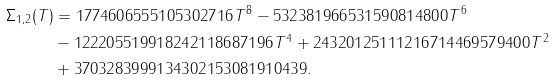<formula> <loc_0><loc_0><loc_500><loc_500>\Sigma _ { 1 , 2 } ( T ) & = 1 7 7 4 6 0 6 5 5 5 1 0 5 3 0 2 7 1 6 T ^ { 8 } - 5 3 2 3 8 1 9 6 6 5 3 1 5 9 0 8 1 4 8 0 0 T ^ { 6 } \\ & - 1 2 2 2 0 5 5 1 9 9 1 8 2 4 2 1 1 8 6 8 7 1 9 6 T ^ { 4 } + 2 4 3 2 0 1 2 5 1 1 1 2 1 6 7 1 4 4 6 9 5 7 9 4 0 0 T ^ { 2 } \\ & + 3 7 0 3 2 8 3 9 9 9 1 3 4 3 0 2 1 5 3 0 8 1 9 1 0 4 3 9 .</formula> 